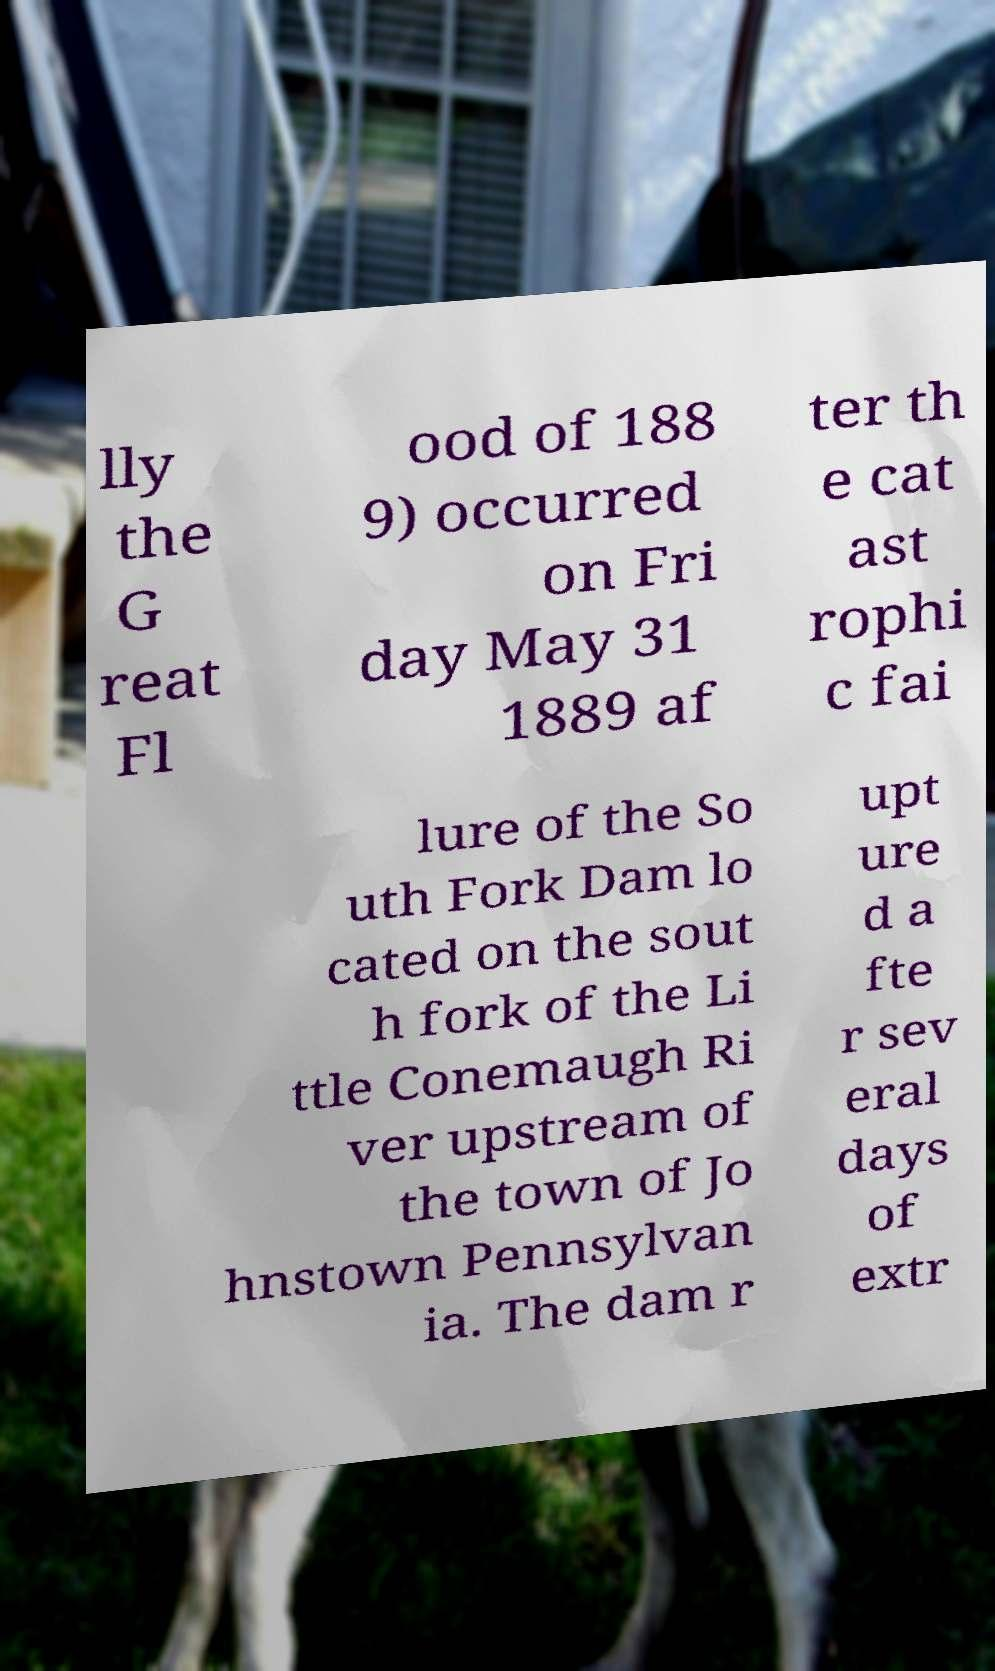Could you assist in decoding the text presented in this image and type it out clearly? lly the G reat Fl ood of 188 9) occurred on Fri day May 31 1889 af ter th e cat ast rophi c fai lure of the So uth Fork Dam lo cated on the sout h fork of the Li ttle Conemaugh Ri ver upstream of the town of Jo hnstown Pennsylvan ia. The dam r upt ure d a fte r sev eral days of extr 